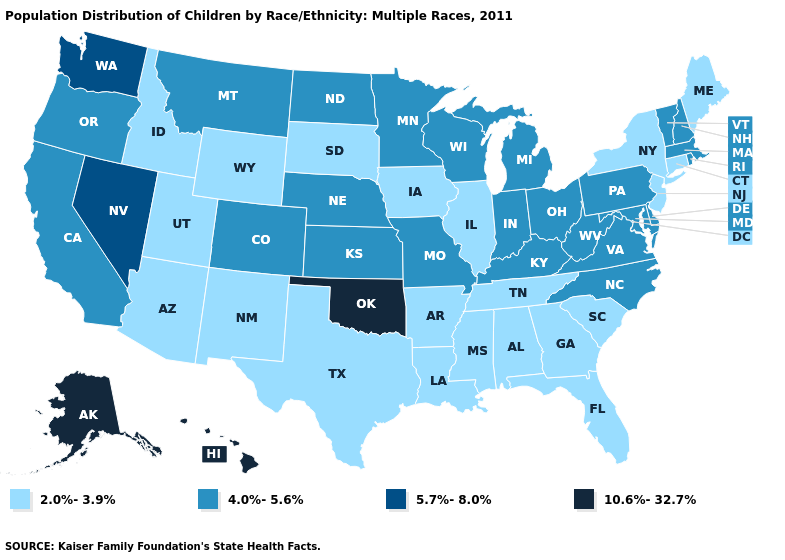What is the lowest value in the USA?
Concise answer only. 2.0%-3.9%. What is the lowest value in the USA?
Concise answer only. 2.0%-3.9%. Name the states that have a value in the range 4.0%-5.6%?
Write a very short answer. California, Colorado, Delaware, Indiana, Kansas, Kentucky, Maryland, Massachusetts, Michigan, Minnesota, Missouri, Montana, Nebraska, New Hampshire, North Carolina, North Dakota, Ohio, Oregon, Pennsylvania, Rhode Island, Vermont, Virginia, West Virginia, Wisconsin. Does Pennsylvania have a lower value than Arizona?
Short answer required. No. Does Ohio have the highest value in the USA?
Quick response, please. No. Does the map have missing data?
Be succinct. No. What is the value of Delaware?
Give a very brief answer. 4.0%-5.6%. Does New Hampshire have a lower value than Michigan?
Concise answer only. No. Is the legend a continuous bar?
Concise answer only. No. Does Tennessee have the same value as Texas?
Give a very brief answer. Yes. Does Maryland have the highest value in the South?
Be succinct. No. Which states hav the highest value in the West?
Write a very short answer. Alaska, Hawaii. What is the value of Wisconsin?
Answer briefly. 4.0%-5.6%. What is the value of Kentucky?
Write a very short answer. 4.0%-5.6%. Name the states that have a value in the range 5.7%-8.0%?
Answer briefly. Nevada, Washington. 